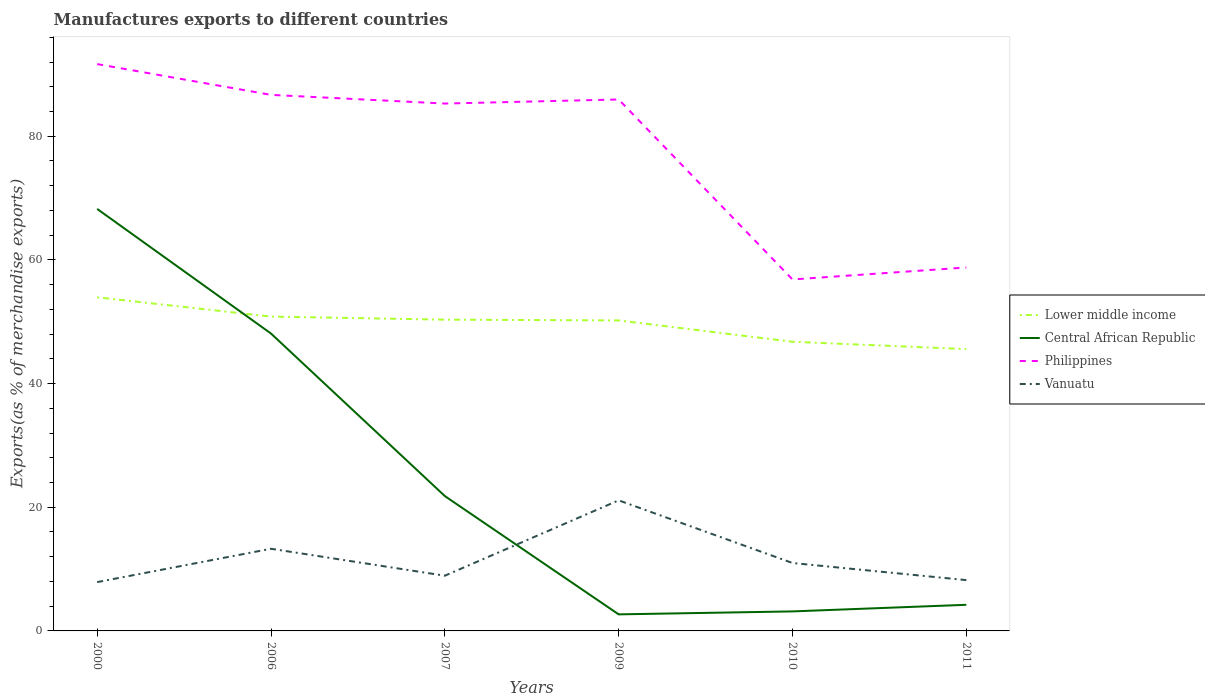Is the number of lines equal to the number of legend labels?
Offer a very short reply. Yes. Across all years, what is the maximum percentage of exports to different countries in Central African Republic?
Offer a very short reply. 2.68. What is the total percentage of exports to different countries in Central African Republic in the graph?
Your answer should be compact. 20.15. What is the difference between the highest and the second highest percentage of exports to different countries in Lower middle income?
Your response must be concise. 8.38. What is the difference between the highest and the lowest percentage of exports to different countries in Vanuatu?
Ensure brevity in your answer.  2. Is the percentage of exports to different countries in Vanuatu strictly greater than the percentage of exports to different countries in Lower middle income over the years?
Your response must be concise. Yes. Does the graph contain any zero values?
Your answer should be very brief. No. Does the graph contain grids?
Your answer should be compact. No. Where does the legend appear in the graph?
Your response must be concise. Center right. How are the legend labels stacked?
Your response must be concise. Vertical. What is the title of the graph?
Your response must be concise. Manufactures exports to different countries. Does "Norway" appear as one of the legend labels in the graph?
Offer a terse response. No. What is the label or title of the X-axis?
Give a very brief answer. Years. What is the label or title of the Y-axis?
Your answer should be compact. Exports(as % of merchandise exports). What is the Exports(as % of merchandise exports) of Lower middle income in 2000?
Provide a succinct answer. 53.95. What is the Exports(as % of merchandise exports) of Central African Republic in 2000?
Make the answer very short. 68.25. What is the Exports(as % of merchandise exports) in Philippines in 2000?
Your answer should be very brief. 91.67. What is the Exports(as % of merchandise exports) in Vanuatu in 2000?
Provide a succinct answer. 7.89. What is the Exports(as % of merchandise exports) of Lower middle income in 2006?
Your response must be concise. 50.83. What is the Exports(as % of merchandise exports) of Central African Republic in 2006?
Provide a succinct answer. 48.09. What is the Exports(as % of merchandise exports) in Philippines in 2006?
Keep it short and to the point. 86.69. What is the Exports(as % of merchandise exports) of Vanuatu in 2006?
Provide a short and direct response. 13.29. What is the Exports(as % of merchandise exports) of Lower middle income in 2007?
Provide a succinct answer. 50.34. What is the Exports(as % of merchandise exports) in Central African Republic in 2007?
Your answer should be very brief. 21.81. What is the Exports(as % of merchandise exports) of Philippines in 2007?
Keep it short and to the point. 85.29. What is the Exports(as % of merchandise exports) of Vanuatu in 2007?
Your answer should be compact. 8.93. What is the Exports(as % of merchandise exports) of Lower middle income in 2009?
Your answer should be compact. 50.21. What is the Exports(as % of merchandise exports) in Central African Republic in 2009?
Give a very brief answer. 2.68. What is the Exports(as % of merchandise exports) in Philippines in 2009?
Make the answer very short. 85.95. What is the Exports(as % of merchandise exports) in Vanuatu in 2009?
Your answer should be very brief. 21.12. What is the Exports(as % of merchandise exports) in Lower middle income in 2010?
Offer a very short reply. 46.76. What is the Exports(as % of merchandise exports) of Central African Republic in 2010?
Ensure brevity in your answer.  3.15. What is the Exports(as % of merchandise exports) in Philippines in 2010?
Ensure brevity in your answer.  56.84. What is the Exports(as % of merchandise exports) of Vanuatu in 2010?
Offer a very short reply. 10.98. What is the Exports(as % of merchandise exports) in Lower middle income in 2011?
Provide a succinct answer. 45.58. What is the Exports(as % of merchandise exports) in Central African Republic in 2011?
Your response must be concise. 4.22. What is the Exports(as % of merchandise exports) in Philippines in 2011?
Your answer should be very brief. 58.78. What is the Exports(as % of merchandise exports) of Vanuatu in 2011?
Offer a terse response. 8.22. Across all years, what is the maximum Exports(as % of merchandise exports) in Lower middle income?
Your answer should be very brief. 53.95. Across all years, what is the maximum Exports(as % of merchandise exports) of Central African Republic?
Provide a succinct answer. 68.25. Across all years, what is the maximum Exports(as % of merchandise exports) in Philippines?
Your answer should be compact. 91.67. Across all years, what is the maximum Exports(as % of merchandise exports) in Vanuatu?
Provide a short and direct response. 21.12. Across all years, what is the minimum Exports(as % of merchandise exports) of Lower middle income?
Make the answer very short. 45.58. Across all years, what is the minimum Exports(as % of merchandise exports) of Central African Republic?
Offer a terse response. 2.68. Across all years, what is the minimum Exports(as % of merchandise exports) of Philippines?
Provide a succinct answer. 56.84. Across all years, what is the minimum Exports(as % of merchandise exports) of Vanuatu?
Offer a terse response. 7.89. What is the total Exports(as % of merchandise exports) in Lower middle income in the graph?
Provide a succinct answer. 297.68. What is the total Exports(as % of merchandise exports) in Central African Republic in the graph?
Offer a very short reply. 148.21. What is the total Exports(as % of merchandise exports) of Philippines in the graph?
Offer a very short reply. 465.22. What is the total Exports(as % of merchandise exports) of Vanuatu in the graph?
Your answer should be very brief. 70.43. What is the difference between the Exports(as % of merchandise exports) of Lower middle income in 2000 and that in 2006?
Offer a terse response. 3.12. What is the difference between the Exports(as % of merchandise exports) in Central African Republic in 2000 and that in 2006?
Your response must be concise. 20.15. What is the difference between the Exports(as % of merchandise exports) in Philippines in 2000 and that in 2006?
Provide a succinct answer. 4.98. What is the difference between the Exports(as % of merchandise exports) of Vanuatu in 2000 and that in 2006?
Keep it short and to the point. -5.39. What is the difference between the Exports(as % of merchandise exports) of Lower middle income in 2000 and that in 2007?
Keep it short and to the point. 3.61. What is the difference between the Exports(as % of merchandise exports) of Central African Republic in 2000 and that in 2007?
Give a very brief answer. 46.43. What is the difference between the Exports(as % of merchandise exports) of Philippines in 2000 and that in 2007?
Make the answer very short. 6.38. What is the difference between the Exports(as % of merchandise exports) of Vanuatu in 2000 and that in 2007?
Your answer should be compact. -1.03. What is the difference between the Exports(as % of merchandise exports) in Lower middle income in 2000 and that in 2009?
Your response must be concise. 3.74. What is the difference between the Exports(as % of merchandise exports) of Central African Republic in 2000 and that in 2009?
Your answer should be compact. 65.57. What is the difference between the Exports(as % of merchandise exports) in Philippines in 2000 and that in 2009?
Provide a succinct answer. 5.72. What is the difference between the Exports(as % of merchandise exports) of Vanuatu in 2000 and that in 2009?
Your answer should be compact. -13.22. What is the difference between the Exports(as % of merchandise exports) of Lower middle income in 2000 and that in 2010?
Your answer should be very brief. 7.19. What is the difference between the Exports(as % of merchandise exports) in Central African Republic in 2000 and that in 2010?
Provide a succinct answer. 65.09. What is the difference between the Exports(as % of merchandise exports) of Philippines in 2000 and that in 2010?
Your answer should be compact. 34.83. What is the difference between the Exports(as % of merchandise exports) of Vanuatu in 2000 and that in 2010?
Keep it short and to the point. -3.09. What is the difference between the Exports(as % of merchandise exports) of Lower middle income in 2000 and that in 2011?
Your answer should be compact. 8.38. What is the difference between the Exports(as % of merchandise exports) in Central African Republic in 2000 and that in 2011?
Offer a terse response. 64.02. What is the difference between the Exports(as % of merchandise exports) in Philippines in 2000 and that in 2011?
Offer a very short reply. 32.89. What is the difference between the Exports(as % of merchandise exports) of Vanuatu in 2000 and that in 2011?
Your answer should be compact. -0.32. What is the difference between the Exports(as % of merchandise exports) in Lower middle income in 2006 and that in 2007?
Your answer should be compact. 0.49. What is the difference between the Exports(as % of merchandise exports) in Central African Republic in 2006 and that in 2007?
Give a very brief answer. 26.28. What is the difference between the Exports(as % of merchandise exports) of Philippines in 2006 and that in 2007?
Give a very brief answer. 1.4. What is the difference between the Exports(as % of merchandise exports) in Vanuatu in 2006 and that in 2007?
Provide a short and direct response. 4.36. What is the difference between the Exports(as % of merchandise exports) of Lower middle income in 2006 and that in 2009?
Ensure brevity in your answer.  0.62. What is the difference between the Exports(as % of merchandise exports) of Central African Republic in 2006 and that in 2009?
Ensure brevity in your answer.  45.42. What is the difference between the Exports(as % of merchandise exports) in Philippines in 2006 and that in 2009?
Your response must be concise. 0.75. What is the difference between the Exports(as % of merchandise exports) in Vanuatu in 2006 and that in 2009?
Your answer should be compact. -7.83. What is the difference between the Exports(as % of merchandise exports) of Lower middle income in 2006 and that in 2010?
Provide a succinct answer. 4.07. What is the difference between the Exports(as % of merchandise exports) of Central African Republic in 2006 and that in 2010?
Give a very brief answer. 44.94. What is the difference between the Exports(as % of merchandise exports) of Philippines in 2006 and that in 2010?
Keep it short and to the point. 29.85. What is the difference between the Exports(as % of merchandise exports) of Vanuatu in 2006 and that in 2010?
Your answer should be very brief. 2.3. What is the difference between the Exports(as % of merchandise exports) in Lower middle income in 2006 and that in 2011?
Offer a very short reply. 5.26. What is the difference between the Exports(as % of merchandise exports) in Central African Republic in 2006 and that in 2011?
Offer a very short reply. 43.87. What is the difference between the Exports(as % of merchandise exports) in Philippines in 2006 and that in 2011?
Offer a very short reply. 27.91. What is the difference between the Exports(as % of merchandise exports) in Vanuatu in 2006 and that in 2011?
Keep it short and to the point. 5.07. What is the difference between the Exports(as % of merchandise exports) in Lower middle income in 2007 and that in 2009?
Your response must be concise. 0.13. What is the difference between the Exports(as % of merchandise exports) in Central African Republic in 2007 and that in 2009?
Provide a succinct answer. 19.13. What is the difference between the Exports(as % of merchandise exports) of Philippines in 2007 and that in 2009?
Keep it short and to the point. -0.66. What is the difference between the Exports(as % of merchandise exports) of Vanuatu in 2007 and that in 2009?
Give a very brief answer. -12.19. What is the difference between the Exports(as % of merchandise exports) of Lower middle income in 2007 and that in 2010?
Ensure brevity in your answer.  3.58. What is the difference between the Exports(as % of merchandise exports) in Central African Republic in 2007 and that in 2010?
Your answer should be very brief. 18.66. What is the difference between the Exports(as % of merchandise exports) of Philippines in 2007 and that in 2010?
Ensure brevity in your answer.  28.45. What is the difference between the Exports(as % of merchandise exports) in Vanuatu in 2007 and that in 2010?
Your answer should be compact. -2.05. What is the difference between the Exports(as % of merchandise exports) of Lower middle income in 2007 and that in 2011?
Ensure brevity in your answer.  4.76. What is the difference between the Exports(as % of merchandise exports) of Central African Republic in 2007 and that in 2011?
Your response must be concise. 17.59. What is the difference between the Exports(as % of merchandise exports) of Philippines in 2007 and that in 2011?
Your answer should be very brief. 26.51. What is the difference between the Exports(as % of merchandise exports) in Vanuatu in 2007 and that in 2011?
Provide a short and direct response. 0.71. What is the difference between the Exports(as % of merchandise exports) in Lower middle income in 2009 and that in 2010?
Provide a succinct answer. 3.45. What is the difference between the Exports(as % of merchandise exports) in Central African Republic in 2009 and that in 2010?
Provide a succinct answer. -0.48. What is the difference between the Exports(as % of merchandise exports) in Philippines in 2009 and that in 2010?
Provide a succinct answer. 29.11. What is the difference between the Exports(as % of merchandise exports) of Vanuatu in 2009 and that in 2010?
Give a very brief answer. 10.13. What is the difference between the Exports(as % of merchandise exports) of Lower middle income in 2009 and that in 2011?
Keep it short and to the point. 4.63. What is the difference between the Exports(as % of merchandise exports) of Central African Republic in 2009 and that in 2011?
Your answer should be very brief. -1.55. What is the difference between the Exports(as % of merchandise exports) in Philippines in 2009 and that in 2011?
Make the answer very short. 27.17. What is the difference between the Exports(as % of merchandise exports) of Vanuatu in 2009 and that in 2011?
Your answer should be very brief. 12.9. What is the difference between the Exports(as % of merchandise exports) in Lower middle income in 2010 and that in 2011?
Provide a succinct answer. 1.19. What is the difference between the Exports(as % of merchandise exports) of Central African Republic in 2010 and that in 2011?
Give a very brief answer. -1.07. What is the difference between the Exports(as % of merchandise exports) of Philippines in 2010 and that in 2011?
Keep it short and to the point. -1.94. What is the difference between the Exports(as % of merchandise exports) in Vanuatu in 2010 and that in 2011?
Your answer should be very brief. 2.77. What is the difference between the Exports(as % of merchandise exports) in Lower middle income in 2000 and the Exports(as % of merchandise exports) in Central African Republic in 2006?
Give a very brief answer. 5.86. What is the difference between the Exports(as % of merchandise exports) in Lower middle income in 2000 and the Exports(as % of merchandise exports) in Philippines in 2006?
Provide a succinct answer. -32.74. What is the difference between the Exports(as % of merchandise exports) of Lower middle income in 2000 and the Exports(as % of merchandise exports) of Vanuatu in 2006?
Your answer should be compact. 40.67. What is the difference between the Exports(as % of merchandise exports) in Central African Republic in 2000 and the Exports(as % of merchandise exports) in Philippines in 2006?
Provide a succinct answer. -18.45. What is the difference between the Exports(as % of merchandise exports) in Central African Republic in 2000 and the Exports(as % of merchandise exports) in Vanuatu in 2006?
Ensure brevity in your answer.  54.96. What is the difference between the Exports(as % of merchandise exports) of Philippines in 2000 and the Exports(as % of merchandise exports) of Vanuatu in 2006?
Ensure brevity in your answer.  78.38. What is the difference between the Exports(as % of merchandise exports) in Lower middle income in 2000 and the Exports(as % of merchandise exports) in Central African Republic in 2007?
Offer a terse response. 32.14. What is the difference between the Exports(as % of merchandise exports) in Lower middle income in 2000 and the Exports(as % of merchandise exports) in Philippines in 2007?
Offer a very short reply. -31.34. What is the difference between the Exports(as % of merchandise exports) of Lower middle income in 2000 and the Exports(as % of merchandise exports) of Vanuatu in 2007?
Ensure brevity in your answer.  45.02. What is the difference between the Exports(as % of merchandise exports) of Central African Republic in 2000 and the Exports(as % of merchandise exports) of Philippines in 2007?
Make the answer very short. -17.04. What is the difference between the Exports(as % of merchandise exports) in Central African Republic in 2000 and the Exports(as % of merchandise exports) in Vanuatu in 2007?
Offer a terse response. 59.32. What is the difference between the Exports(as % of merchandise exports) of Philippines in 2000 and the Exports(as % of merchandise exports) of Vanuatu in 2007?
Ensure brevity in your answer.  82.74. What is the difference between the Exports(as % of merchandise exports) in Lower middle income in 2000 and the Exports(as % of merchandise exports) in Central African Republic in 2009?
Provide a succinct answer. 51.28. What is the difference between the Exports(as % of merchandise exports) of Lower middle income in 2000 and the Exports(as % of merchandise exports) of Philippines in 2009?
Ensure brevity in your answer.  -31.99. What is the difference between the Exports(as % of merchandise exports) of Lower middle income in 2000 and the Exports(as % of merchandise exports) of Vanuatu in 2009?
Keep it short and to the point. 32.84. What is the difference between the Exports(as % of merchandise exports) of Central African Republic in 2000 and the Exports(as % of merchandise exports) of Philippines in 2009?
Keep it short and to the point. -17.7. What is the difference between the Exports(as % of merchandise exports) in Central African Republic in 2000 and the Exports(as % of merchandise exports) in Vanuatu in 2009?
Make the answer very short. 47.13. What is the difference between the Exports(as % of merchandise exports) in Philippines in 2000 and the Exports(as % of merchandise exports) in Vanuatu in 2009?
Provide a succinct answer. 70.55. What is the difference between the Exports(as % of merchandise exports) of Lower middle income in 2000 and the Exports(as % of merchandise exports) of Central African Republic in 2010?
Your response must be concise. 50.8. What is the difference between the Exports(as % of merchandise exports) of Lower middle income in 2000 and the Exports(as % of merchandise exports) of Philippines in 2010?
Offer a terse response. -2.89. What is the difference between the Exports(as % of merchandise exports) of Lower middle income in 2000 and the Exports(as % of merchandise exports) of Vanuatu in 2010?
Make the answer very short. 42.97. What is the difference between the Exports(as % of merchandise exports) of Central African Republic in 2000 and the Exports(as % of merchandise exports) of Philippines in 2010?
Provide a short and direct response. 11.4. What is the difference between the Exports(as % of merchandise exports) of Central African Republic in 2000 and the Exports(as % of merchandise exports) of Vanuatu in 2010?
Your response must be concise. 57.26. What is the difference between the Exports(as % of merchandise exports) of Philippines in 2000 and the Exports(as % of merchandise exports) of Vanuatu in 2010?
Your answer should be compact. 80.69. What is the difference between the Exports(as % of merchandise exports) of Lower middle income in 2000 and the Exports(as % of merchandise exports) of Central African Republic in 2011?
Ensure brevity in your answer.  49.73. What is the difference between the Exports(as % of merchandise exports) in Lower middle income in 2000 and the Exports(as % of merchandise exports) in Philippines in 2011?
Give a very brief answer. -4.82. What is the difference between the Exports(as % of merchandise exports) of Lower middle income in 2000 and the Exports(as % of merchandise exports) of Vanuatu in 2011?
Ensure brevity in your answer.  45.74. What is the difference between the Exports(as % of merchandise exports) of Central African Republic in 2000 and the Exports(as % of merchandise exports) of Philippines in 2011?
Provide a short and direct response. 9.47. What is the difference between the Exports(as % of merchandise exports) of Central African Republic in 2000 and the Exports(as % of merchandise exports) of Vanuatu in 2011?
Make the answer very short. 60.03. What is the difference between the Exports(as % of merchandise exports) in Philippines in 2000 and the Exports(as % of merchandise exports) in Vanuatu in 2011?
Offer a very short reply. 83.45. What is the difference between the Exports(as % of merchandise exports) of Lower middle income in 2006 and the Exports(as % of merchandise exports) of Central African Republic in 2007?
Make the answer very short. 29.02. What is the difference between the Exports(as % of merchandise exports) of Lower middle income in 2006 and the Exports(as % of merchandise exports) of Philippines in 2007?
Provide a succinct answer. -34.46. What is the difference between the Exports(as % of merchandise exports) in Lower middle income in 2006 and the Exports(as % of merchandise exports) in Vanuatu in 2007?
Offer a terse response. 41.9. What is the difference between the Exports(as % of merchandise exports) of Central African Republic in 2006 and the Exports(as % of merchandise exports) of Philippines in 2007?
Ensure brevity in your answer.  -37.2. What is the difference between the Exports(as % of merchandise exports) of Central African Republic in 2006 and the Exports(as % of merchandise exports) of Vanuatu in 2007?
Keep it short and to the point. 39.17. What is the difference between the Exports(as % of merchandise exports) in Philippines in 2006 and the Exports(as % of merchandise exports) in Vanuatu in 2007?
Ensure brevity in your answer.  77.76. What is the difference between the Exports(as % of merchandise exports) in Lower middle income in 2006 and the Exports(as % of merchandise exports) in Central African Republic in 2009?
Keep it short and to the point. 48.15. What is the difference between the Exports(as % of merchandise exports) in Lower middle income in 2006 and the Exports(as % of merchandise exports) in Philippines in 2009?
Your answer should be compact. -35.11. What is the difference between the Exports(as % of merchandise exports) in Lower middle income in 2006 and the Exports(as % of merchandise exports) in Vanuatu in 2009?
Provide a short and direct response. 29.72. What is the difference between the Exports(as % of merchandise exports) of Central African Republic in 2006 and the Exports(as % of merchandise exports) of Philippines in 2009?
Offer a terse response. -37.85. What is the difference between the Exports(as % of merchandise exports) in Central African Republic in 2006 and the Exports(as % of merchandise exports) in Vanuatu in 2009?
Offer a terse response. 26.98. What is the difference between the Exports(as % of merchandise exports) of Philippines in 2006 and the Exports(as % of merchandise exports) of Vanuatu in 2009?
Give a very brief answer. 65.58. What is the difference between the Exports(as % of merchandise exports) in Lower middle income in 2006 and the Exports(as % of merchandise exports) in Central African Republic in 2010?
Your answer should be compact. 47.68. What is the difference between the Exports(as % of merchandise exports) in Lower middle income in 2006 and the Exports(as % of merchandise exports) in Philippines in 2010?
Ensure brevity in your answer.  -6.01. What is the difference between the Exports(as % of merchandise exports) in Lower middle income in 2006 and the Exports(as % of merchandise exports) in Vanuatu in 2010?
Make the answer very short. 39.85. What is the difference between the Exports(as % of merchandise exports) of Central African Republic in 2006 and the Exports(as % of merchandise exports) of Philippines in 2010?
Your answer should be very brief. -8.75. What is the difference between the Exports(as % of merchandise exports) of Central African Republic in 2006 and the Exports(as % of merchandise exports) of Vanuatu in 2010?
Offer a terse response. 37.11. What is the difference between the Exports(as % of merchandise exports) in Philippines in 2006 and the Exports(as % of merchandise exports) in Vanuatu in 2010?
Ensure brevity in your answer.  75.71. What is the difference between the Exports(as % of merchandise exports) in Lower middle income in 2006 and the Exports(as % of merchandise exports) in Central African Republic in 2011?
Provide a succinct answer. 46.61. What is the difference between the Exports(as % of merchandise exports) in Lower middle income in 2006 and the Exports(as % of merchandise exports) in Philippines in 2011?
Your answer should be compact. -7.95. What is the difference between the Exports(as % of merchandise exports) of Lower middle income in 2006 and the Exports(as % of merchandise exports) of Vanuatu in 2011?
Offer a very short reply. 42.62. What is the difference between the Exports(as % of merchandise exports) of Central African Republic in 2006 and the Exports(as % of merchandise exports) of Philippines in 2011?
Offer a very short reply. -10.68. What is the difference between the Exports(as % of merchandise exports) of Central African Republic in 2006 and the Exports(as % of merchandise exports) of Vanuatu in 2011?
Your response must be concise. 39.88. What is the difference between the Exports(as % of merchandise exports) of Philippines in 2006 and the Exports(as % of merchandise exports) of Vanuatu in 2011?
Offer a terse response. 78.47. What is the difference between the Exports(as % of merchandise exports) in Lower middle income in 2007 and the Exports(as % of merchandise exports) in Central African Republic in 2009?
Your answer should be compact. 47.66. What is the difference between the Exports(as % of merchandise exports) of Lower middle income in 2007 and the Exports(as % of merchandise exports) of Philippines in 2009?
Your response must be concise. -35.61. What is the difference between the Exports(as % of merchandise exports) in Lower middle income in 2007 and the Exports(as % of merchandise exports) in Vanuatu in 2009?
Ensure brevity in your answer.  29.22. What is the difference between the Exports(as % of merchandise exports) in Central African Republic in 2007 and the Exports(as % of merchandise exports) in Philippines in 2009?
Ensure brevity in your answer.  -64.14. What is the difference between the Exports(as % of merchandise exports) in Central African Republic in 2007 and the Exports(as % of merchandise exports) in Vanuatu in 2009?
Your response must be concise. 0.69. What is the difference between the Exports(as % of merchandise exports) of Philippines in 2007 and the Exports(as % of merchandise exports) of Vanuatu in 2009?
Ensure brevity in your answer.  64.17. What is the difference between the Exports(as % of merchandise exports) of Lower middle income in 2007 and the Exports(as % of merchandise exports) of Central African Republic in 2010?
Keep it short and to the point. 47.19. What is the difference between the Exports(as % of merchandise exports) in Lower middle income in 2007 and the Exports(as % of merchandise exports) in Philippines in 2010?
Provide a short and direct response. -6.5. What is the difference between the Exports(as % of merchandise exports) of Lower middle income in 2007 and the Exports(as % of merchandise exports) of Vanuatu in 2010?
Ensure brevity in your answer.  39.36. What is the difference between the Exports(as % of merchandise exports) in Central African Republic in 2007 and the Exports(as % of merchandise exports) in Philippines in 2010?
Give a very brief answer. -35.03. What is the difference between the Exports(as % of merchandise exports) of Central African Republic in 2007 and the Exports(as % of merchandise exports) of Vanuatu in 2010?
Your response must be concise. 10.83. What is the difference between the Exports(as % of merchandise exports) in Philippines in 2007 and the Exports(as % of merchandise exports) in Vanuatu in 2010?
Keep it short and to the point. 74.31. What is the difference between the Exports(as % of merchandise exports) of Lower middle income in 2007 and the Exports(as % of merchandise exports) of Central African Republic in 2011?
Provide a succinct answer. 46.12. What is the difference between the Exports(as % of merchandise exports) of Lower middle income in 2007 and the Exports(as % of merchandise exports) of Philippines in 2011?
Offer a terse response. -8.44. What is the difference between the Exports(as % of merchandise exports) in Lower middle income in 2007 and the Exports(as % of merchandise exports) in Vanuatu in 2011?
Offer a terse response. 42.12. What is the difference between the Exports(as % of merchandise exports) of Central African Republic in 2007 and the Exports(as % of merchandise exports) of Philippines in 2011?
Offer a terse response. -36.97. What is the difference between the Exports(as % of merchandise exports) in Central African Republic in 2007 and the Exports(as % of merchandise exports) in Vanuatu in 2011?
Provide a succinct answer. 13.59. What is the difference between the Exports(as % of merchandise exports) in Philippines in 2007 and the Exports(as % of merchandise exports) in Vanuatu in 2011?
Offer a terse response. 77.07. What is the difference between the Exports(as % of merchandise exports) of Lower middle income in 2009 and the Exports(as % of merchandise exports) of Central African Republic in 2010?
Offer a terse response. 47.06. What is the difference between the Exports(as % of merchandise exports) of Lower middle income in 2009 and the Exports(as % of merchandise exports) of Philippines in 2010?
Ensure brevity in your answer.  -6.63. What is the difference between the Exports(as % of merchandise exports) of Lower middle income in 2009 and the Exports(as % of merchandise exports) of Vanuatu in 2010?
Make the answer very short. 39.23. What is the difference between the Exports(as % of merchandise exports) of Central African Republic in 2009 and the Exports(as % of merchandise exports) of Philippines in 2010?
Provide a succinct answer. -54.16. What is the difference between the Exports(as % of merchandise exports) of Central African Republic in 2009 and the Exports(as % of merchandise exports) of Vanuatu in 2010?
Make the answer very short. -8.3. What is the difference between the Exports(as % of merchandise exports) of Philippines in 2009 and the Exports(as % of merchandise exports) of Vanuatu in 2010?
Your answer should be compact. 74.96. What is the difference between the Exports(as % of merchandise exports) in Lower middle income in 2009 and the Exports(as % of merchandise exports) in Central African Republic in 2011?
Your answer should be very brief. 45.99. What is the difference between the Exports(as % of merchandise exports) of Lower middle income in 2009 and the Exports(as % of merchandise exports) of Philippines in 2011?
Offer a very short reply. -8.57. What is the difference between the Exports(as % of merchandise exports) of Lower middle income in 2009 and the Exports(as % of merchandise exports) of Vanuatu in 2011?
Give a very brief answer. 41.99. What is the difference between the Exports(as % of merchandise exports) in Central African Republic in 2009 and the Exports(as % of merchandise exports) in Philippines in 2011?
Make the answer very short. -56.1. What is the difference between the Exports(as % of merchandise exports) in Central African Republic in 2009 and the Exports(as % of merchandise exports) in Vanuatu in 2011?
Provide a short and direct response. -5.54. What is the difference between the Exports(as % of merchandise exports) in Philippines in 2009 and the Exports(as % of merchandise exports) in Vanuatu in 2011?
Your answer should be very brief. 77.73. What is the difference between the Exports(as % of merchandise exports) of Lower middle income in 2010 and the Exports(as % of merchandise exports) of Central African Republic in 2011?
Keep it short and to the point. 42.54. What is the difference between the Exports(as % of merchandise exports) of Lower middle income in 2010 and the Exports(as % of merchandise exports) of Philippines in 2011?
Make the answer very short. -12.02. What is the difference between the Exports(as % of merchandise exports) of Lower middle income in 2010 and the Exports(as % of merchandise exports) of Vanuatu in 2011?
Your answer should be compact. 38.55. What is the difference between the Exports(as % of merchandise exports) of Central African Republic in 2010 and the Exports(as % of merchandise exports) of Philippines in 2011?
Your answer should be very brief. -55.62. What is the difference between the Exports(as % of merchandise exports) of Central African Republic in 2010 and the Exports(as % of merchandise exports) of Vanuatu in 2011?
Provide a short and direct response. -5.06. What is the difference between the Exports(as % of merchandise exports) of Philippines in 2010 and the Exports(as % of merchandise exports) of Vanuatu in 2011?
Your response must be concise. 48.62. What is the average Exports(as % of merchandise exports) of Lower middle income per year?
Provide a short and direct response. 49.61. What is the average Exports(as % of merchandise exports) of Central African Republic per year?
Make the answer very short. 24.7. What is the average Exports(as % of merchandise exports) of Philippines per year?
Ensure brevity in your answer.  77.54. What is the average Exports(as % of merchandise exports) in Vanuatu per year?
Offer a very short reply. 11.74. In the year 2000, what is the difference between the Exports(as % of merchandise exports) of Lower middle income and Exports(as % of merchandise exports) of Central African Republic?
Provide a succinct answer. -14.29. In the year 2000, what is the difference between the Exports(as % of merchandise exports) in Lower middle income and Exports(as % of merchandise exports) in Philippines?
Give a very brief answer. -37.72. In the year 2000, what is the difference between the Exports(as % of merchandise exports) of Lower middle income and Exports(as % of merchandise exports) of Vanuatu?
Provide a short and direct response. 46.06. In the year 2000, what is the difference between the Exports(as % of merchandise exports) of Central African Republic and Exports(as % of merchandise exports) of Philippines?
Your response must be concise. -23.43. In the year 2000, what is the difference between the Exports(as % of merchandise exports) in Central African Republic and Exports(as % of merchandise exports) in Vanuatu?
Keep it short and to the point. 60.35. In the year 2000, what is the difference between the Exports(as % of merchandise exports) of Philippines and Exports(as % of merchandise exports) of Vanuatu?
Give a very brief answer. 83.78. In the year 2006, what is the difference between the Exports(as % of merchandise exports) of Lower middle income and Exports(as % of merchandise exports) of Central African Republic?
Ensure brevity in your answer.  2.74. In the year 2006, what is the difference between the Exports(as % of merchandise exports) in Lower middle income and Exports(as % of merchandise exports) in Philippines?
Your answer should be compact. -35.86. In the year 2006, what is the difference between the Exports(as % of merchandise exports) in Lower middle income and Exports(as % of merchandise exports) in Vanuatu?
Your answer should be compact. 37.55. In the year 2006, what is the difference between the Exports(as % of merchandise exports) in Central African Republic and Exports(as % of merchandise exports) in Philippines?
Make the answer very short. -38.6. In the year 2006, what is the difference between the Exports(as % of merchandise exports) in Central African Republic and Exports(as % of merchandise exports) in Vanuatu?
Provide a succinct answer. 34.81. In the year 2006, what is the difference between the Exports(as % of merchandise exports) of Philippines and Exports(as % of merchandise exports) of Vanuatu?
Your response must be concise. 73.41. In the year 2007, what is the difference between the Exports(as % of merchandise exports) in Lower middle income and Exports(as % of merchandise exports) in Central African Republic?
Your answer should be compact. 28.53. In the year 2007, what is the difference between the Exports(as % of merchandise exports) in Lower middle income and Exports(as % of merchandise exports) in Philippines?
Offer a terse response. -34.95. In the year 2007, what is the difference between the Exports(as % of merchandise exports) in Lower middle income and Exports(as % of merchandise exports) in Vanuatu?
Your answer should be very brief. 41.41. In the year 2007, what is the difference between the Exports(as % of merchandise exports) of Central African Republic and Exports(as % of merchandise exports) of Philippines?
Ensure brevity in your answer.  -63.48. In the year 2007, what is the difference between the Exports(as % of merchandise exports) of Central African Republic and Exports(as % of merchandise exports) of Vanuatu?
Offer a very short reply. 12.88. In the year 2007, what is the difference between the Exports(as % of merchandise exports) of Philippines and Exports(as % of merchandise exports) of Vanuatu?
Provide a short and direct response. 76.36. In the year 2009, what is the difference between the Exports(as % of merchandise exports) in Lower middle income and Exports(as % of merchandise exports) in Central African Republic?
Make the answer very short. 47.53. In the year 2009, what is the difference between the Exports(as % of merchandise exports) of Lower middle income and Exports(as % of merchandise exports) of Philippines?
Offer a very short reply. -35.74. In the year 2009, what is the difference between the Exports(as % of merchandise exports) in Lower middle income and Exports(as % of merchandise exports) in Vanuatu?
Offer a terse response. 29.09. In the year 2009, what is the difference between the Exports(as % of merchandise exports) of Central African Republic and Exports(as % of merchandise exports) of Philippines?
Provide a succinct answer. -83.27. In the year 2009, what is the difference between the Exports(as % of merchandise exports) of Central African Republic and Exports(as % of merchandise exports) of Vanuatu?
Your answer should be compact. -18.44. In the year 2009, what is the difference between the Exports(as % of merchandise exports) in Philippines and Exports(as % of merchandise exports) in Vanuatu?
Your answer should be compact. 64.83. In the year 2010, what is the difference between the Exports(as % of merchandise exports) in Lower middle income and Exports(as % of merchandise exports) in Central African Republic?
Your response must be concise. 43.61. In the year 2010, what is the difference between the Exports(as % of merchandise exports) of Lower middle income and Exports(as % of merchandise exports) of Philippines?
Provide a succinct answer. -10.08. In the year 2010, what is the difference between the Exports(as % of merchandise exports) in Lower middle income and Exports(as % of merchandise exports) in Vanuatu?
Give a very brief answer. 35.78. In the year 2010, what is the difference between the Exports(as % of merchandise exports) in Central African Republic and Exports(as % of merchandise exports) in Philippines?
Ensure brevity in your answer.  -53.69. In the year 2010, what is the difference between the Exports(as % of merchandise exports) of Central African Republic and Exports(as % of merchandise exports) of Vanuatu?
Your answer should be very brief. -7.83. In the year 2010, what is the difference between the Exports(as % of merchandise exports) of Philippines and Exports(as % of merchandise exports) of Vanuatu?
Provide a short and direct response. 45.86. In the year 2011, what is the difference between the Exports(as % of merchandise exports) of Lower middle income and Exports(as % of merchandise exports) of Central African Republic?
Your answer should be very brief. 41.35. In the year 2011, what is the difference between the Exports(as % of merchandise exports) of Lower middle income and Exports(as % of merchandise exports) of Philippines?
Provide a succinct answer. -13.2. In the year 2011, what is the difference between the Exports(as % of merchandise exports) of Lower middle income and Exports(as % of merchandise exports) of Vanuatu?
Provide a short and direct response. 37.36. In the year 2011, what is the difference between the Exports(as % of merchandise exports) of Central African Republic and Exports(as % of merchandise exports) of Philippines?
Offer a terse response. -54.55. In the year 2011, what is the difference between the Exports(as % of merchandise exports) of Central African Republic and Exports(as % of merchandise exports) of Vanuatu?
Ensure brevity in your answer.  -3.99. In the year 2011, what is the difference between the Exports(as % of merchandise exports) in Philippines and Exports(as % of merchandise exports) in Vanuatu?
Your response must be concise. 50.56. What is the ratio of the Exports(as % of merchandise exports) of Lower middle income in 2000 to that in 2006?
Offer a very short reply. 1.06. What is the ratio of the Exports(as % of merchandise exports) of Central African Republic in 2000 to that in 2006?
Make the answer very short. 1.42. What is the ratio of the Exports(as % of merchandise exports) of Philippines in 2000 to that in 2006?
Offer a terse response. 1.06. What is the ratio of the Exports(as % of merchandise exports) in Vanuatu in 2000 to that in 2006?
Your response must be concise. 0.59. What is the ratio of the Exports(as % of merchandise exports) of Lower middle income in 2000 to that in 2007?
Give a very brief answer. 1.07. What is the ratio of the Exports(as % of merchandise exports) in Central African Republic in 2000 to that in 2007?
Your response must be concise. 3.13. What is the ratio of the Exports(as % of merchandise exports) in Philippines in 2000 to that in 2007?
Your answer should be compact. 1.07. What is the ratio of the Exports(as % of merchandise exports) of Vanuatu in 2000 to that in 2007?
Ensure brevity in your answer.  0.88. What is the ratio of the Exports(as % of merchandise exports) in Lower middle income in 2000 to that in 2009?
Offer a terse response. 1.07. What is the ratio of the Exports(as % of merchandise exports) of Central African Republic in 2000 to that in 2009?
Provide a succinct answer. 25.47. What is the ratio of the Exports(as % of merchandise exports) of Philippines in 2000 to that in 2009?
Provide a short and direct response. 1.07. What is the ratio of the Exports(as % of merchandise exports) of Vanuatu in 2000 to that in 2009?
Keep it short and to the point. 0.37. What is the ratio of the Exports(as % of merchandise exports) of Lower middle income in 2000 to that in 2010?
Provide a short and direct response. 1.15. What is the ratio of the Exports(as % of merchandise exports) in Central African Republic in 2000 to that in 2010?
Give a very brief answer. 21.63. What is the ratio of the Exports(as % of merchandise exports) of Philippines in 2000 to that in 2010?
Your answer should be compact. 1.61. What is the ratio of the Exports(as % of merchandise exports) in Vanuatu in 2000 to that in 2010?
Your response must be concise. 0.72. What is the ratio of the Exports(as % of merchandise exports) in Lower middle income in 2000 to that in 2011?
Your answer should be very brief. 1.18. What is the ratio of the Exports(as % of merchandise exports) of Central African Republic in 2000 to that in 2011?
Provide a succinct answer. 16.16. What is the ratio of the Exports(as % of merchandise exports) of Philippines in 2000 to that in 2011?
Your answer should be compact. 1.56. What is the ratio of the Exports(as % of merchandise exports) of Vanuatu in 2000 to that in 2011?
Offer a very short reply. 0.96. What is the ratio of the Exports(as % of merchandise exports) of Lower middle income in 2006 to that in 2007?
Ensure brevity in your answer.  1.01. What is the ratio of the Exports(as % of merchandise exports) of Central African Republic in 2006 to that in 2007?
Offer a terse response. 2.21. What is the ratio of the Exports(as % of merchandise exports) in Philippines in 2006 to that in 2007?
Offer a terse response. 1.02. What is the ratio of the Exports(as % of merchandise exports) in Vanuatu in 2006 to that in 2007?
Your answer should be compact. 1.49. What is the ratio of the Exports(as % of merchandise exports) in Lower middle income in 2006 to that in 2009?
Make the answer very short. 1.01. What is the ratio of the Exports(as % of merchandise exports) in Central African Republic in 2006 to that in 2009?
Your answer should be very brief. 17.95. What is the ratio of the Exports(as % of merchandise exports) in Philippines in 2006 to that in 2009?
Offer a terse response. 1.01. What is the ratio of the Exports(as % of merchandise exports) in Vanuatu in 2006 to that in 2009?
Your answer should be very brief. 0.63. What is the ratio of the Exports(as % of merchandise exports) of Lower middle income in 2006 to that in 2010?
Offer a very short reply. 1.09. What is the ratio of the Exports(as % of merchandise exports) of Central African Republic in 2006 to that in 2010?
Offer a terse response. 15.24. What is the ratio of the Exports(as % of merchandise exports) in Philippines in 2006 to that in 2010?
Provide a succinct answer. 1.53. What is the ratio of the Exports(as % of merchandise exports) in Vanuatu in 2006 to that in 2010?
Ensure brevity in your answer.  1.21. What is the ratio of the Exports(as % of merchandise exports) of Lower middle income in 2006 to that in 2011?
Provide a succinct answer. 1.12. What is the ratio of the Exports(as % of merchandise exports) in Central African Republic in 2006 to that in 2011?
Make the answer very short. 11.38. What is the ratio of the Exports(as % of merchandise exports) in Philippines in 2006 to that in 2011?
Your response must be concise. 1.47. What is the ratio of the Exports(as % of merchandise exports) in Vanuatu in 2006 to that in 2011?
Provide a succinct answer. 1.62. What is the ratio of the Exports(as % of merchandise exports) of Lower middle income in 2007 to that in 2009?
Make the answer very short. 1. What is the ratio of the Exports(as % of merchandise exports) in Central African Republic in 2007 to that in 2009?
Provide a short and direct response. 8.14. What is the ratio of the Exports(as % of merchandise exports) of Philippines in 2007 to that in 2009?
Provide a succinct answer. 0.99. What is the ratio of the Exports(as % of merchandise exports) of Vanuatu in 2007 to that in 2009?
Your answer should be compact. 0.42. What is the ratio of the Exports(as % of merchandise exports) in Lower middle income in 2007 to that in 2010?
Provide a short and direct response. 1.08. What is the ratio of the Exports(as % of merchandise exports) in Central African Republic in 2007 to that in 2010?
Ensure brevity in your answer.  6.91. What is the ratio of the Exports(as % of merchandise exports) in Philippines in 2007 to that in 2010?
Offer a terse response. 1.5. What is the ratio of the Exports(as % of merchandise exports) of Vanuatu in 2007 to that in 2010?
Make the answer very short. 0.81. What is the ratio of the Exports(as % of merchandise exports) in Lower middle income in 2007 to that in 2011?
Your response must be concise. 1.1. What is the ratio of the Exports(as % of merchandise exports) of Central African Republic in 2007 to that in 2011?
Give a very brief answer. 5.16. What is the ratio of the Exports(as % of merchandise exports) of Philippines in 2007 to that in 2011?
Your answer should be compact. 1.45. What is the ratio of the Exports(as % of merchandise exports) of Vanuatu in 2007 to that in 2011?
Ensure brevity in your answer.  1.09. What is the ratio of the Exports(as % of merchandise exports) in Lower middle income in 2009 to that in 2010?
Make the answer very short. 1.07. What is the ratio of the Exports(as % of merchandise exports) of Central African Republic in 2009 to that in 2010?
Your answer should be very brief. 0.85. What is the ratio of the Exports(as % of merchandise exports) in Philippines in 2009 to that in 2010?
Make the answer very short. 1.51. What is the ratio of the Exports(as % of merchandise exports) of Vanuatu in 2009 to that in 2010?
Keep it short and to the point. 1.92. What is the ratio of the Exports(as % of merchandise exports) in Lower middle income in 2009 to that in 2011?
Provide a short and direct response. 1.1. What is the ratio of the Exports(as % of merchandise exports) in Central African Republic in 2009 to that in 2011?
Your answer should be very brief. 0.63. What is the ratio of the Exports(as % of merchandise exports) in Philippines in 2009 to that in 2011?
Your response must be concise. 1.46. What is the ratio of the Exports(as % of merchandise exports) in Vanuatu in 2009 to that in 2011?
Provide a succinct answer. 2.57. What is the ratio of the Exports(as % of merchandise exports) of Central African Republic in 2010 to that in 2011?
Your response must be concise. 0.75. What is the ratio of the Exports(as % of merchandise exports) in Philippines in 2010 to that in 2011?
Your answer should be very brief. 0.97. What is the ratio of the Exports(as % of merchandise exports) in Vanuatu in 2010 to that in 2011?
Offer a terse response. 1.34. What is the difference between the highest and the second highest Exports(as % of merchandise exports) in Lower middle income?
Make the answer very short. 3.12. What is the difference between the highest and the second highest Exports(as % of merchandise exports) in Central African Republic?
Provide a short and direct response. 20.15. What is the difference between the highest and the second highest Exports(as % of merchandise exports) in Philippines?
Offer a very short reply. 4.98. What is the difference between the highest and the second highest Exports(as % of merchandise exports) in Vanuatu?
Make the answer very short. 7.83. What is the difference between the highest and the lowest Exports(as % of merchandise exports) of Lower middle income?
Offer a terse response. 8.38. What is the difference between the highest and the lowest Exports(as % of merchandise exports) in Central African Republic?
Ensure brevity in your answer.  65.57. What is the difference between the highest and the lowest Exports(as % of merchandise exports) in Philippines?
Ensure brevity in your answer.  34.83. What is the difference between the highest and the lowest Exports(as % of merchandise exports) of Vanuatu?
Ensure brevity in your answer.  13.22. 